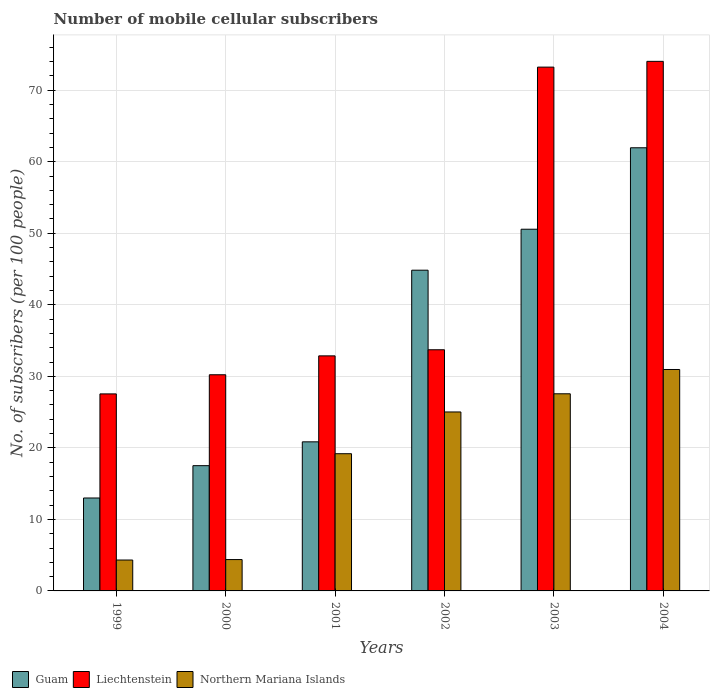How many groups of bars are there?
Your answer should be very brief. 6. Are the number of bars per tick equal to the number of legend labels?
Your answer should be very brief. Yes. Are the number of bars on each tick of the X-axis equal?
Offer a terse response. Yes. How many bars are there on the 3rd tick from the left?
Ensure brevity in your answer.  3. What is the label of the 5th group of bars from the left?
Keep it short and to the point. 2003. What is the number of mobile cellular subscribers in Guam in 2003?
Give a very brief answer. 50.56. Across all years, what is the maximum number of mobile cellular subscribers in Guam?
Provide a succinct answer. 61.95. Across all years, what is the minimum number of mobile cellular subscribers in Northern Mariana Islands?
Your answer should be very brief. 4.32. In which year was the number of mobile cellular subscribers in Liechtenstein minimum?
Make the answer very short. 1999. What is the total number of mobile cellular subscribers in Guam in the graph?
Make the answer very short. 208.69. What is the difference between the number of mobile cellular subscribers in Liechtenstein in 2000 and that in 2002?
Your response must be concise. -3.49. What is the difference between the number of mobile cellular subscribers in Northern Mariana Islands in 2000 and the number of mobile cellular subscribers in Guam in 2001?
Offer a terse response. -16.46. What is the average number of mobile cellular subscribers in Guam per year?
Provide a short and direct response. 34.78. In the year 2001, what is the difference between the number of mobile cellular subscribers in Northern Mariana Islands and number of mobile cellular subscribers in Liechtenstein?
Give a very brief answer. -13.68. What is the ratio of the number of mobile cellular subscribers in Northern Mariana Islands in 2000 to that in 2003?
Your answer should be compact. 0.16. Is the number of mobile cellular subscribers in Liechtenstein in 2001 less than that in 2003?
Give a very brief answer. Yes. Is the difference between the number of mobile cellular subscribers in Northern Mariana Islands in 2000 and 2004 greater than the difference between the number of mobile cellular subscribers in Liechtenstein in 2000 and 2004?
Your answer should be very brief. Yes. What is the difference between the highest and the second highest number of mobile cellular subscribers in Northern Mariana Islands?
Your answer should be compact. 3.4. What is the difference between the highest and the lowest number of mobile cellular subscribers in Liechtenstein?
Provide a succinct answer. 46.49. In how many years, is the number of mobile cellular subscribers in Northern Mariana Islands greater than the average number of mobile cellular subscribers in Northern Mariana Islands taken over all years?
Ensure brevity in your answer.  4. What does the 1st bar from the left in 1999 represents?
Keep it short and to the point. Guam. What does the 3rd bar from the right in 1999 represents?
Your answer should be very brief. Guam. How many years are there in the graph?
Keep it short and to the point. 6. Does the graph contain any zero values?
Offer a very short reply. No. How are the legend labels stacked?
Ensure brevity in your answer.  Horizontal. What is the title of the graph?
Your response must be concise. Number of mobile cellular subscribers. What is the label or title of the Y-axis?
Make the answer very short. No. of subscribers (per 100 people). What is the No. of subscribers (per 100 people) of Guam in 1999?
Ensure brevity in your answer.  12.99. What is the No. of subscribers (per 100 people) of Liechtenstein in 1999?
Provide a succinct answer. 27.54. What is the No. of subscribers (per 100 people) in Northern Mariana Islands in 1999?
Provide a short and direct response. 4.32. What is the No. of subscribers (per 100 people) of Guam in 2000?
Give a very brief answer. 17.51. What is the No. of subscribers (per 100 people) in Liechtenstein in 2000?
Make the answer very short. 30.22. What is the No. of subscribers (per 100 people) of Northern Mariana Islands in 2000?
Keep it short and to the point. 4.38. What is the No. of subscribers (per 100 people) of Guam in 2001?
Your answer should be very brief. 20.84. What is the No. of subscribers (per 100 people) of Liechtenstein in 2001?
Your response must be concise. 32.86. What is the No. of subscribers (per 100 people) of Northern Mariana Islands in 2001?
Keep it short and to the point. 19.18. What is the No. of subscribers (per 100 people) in Guam in 2002?
Offer a very short reply. 44.84. What is the No. of subscribers (per 100 people) of Liechtenstein in 2002?
Give a very brief answer. 33.71. What is the No. of subscribers (per 100 people) of Northern Mariana Islands in 2002?
Keep it short and to the point. 25.02. What is the No. of subscribers (per 100 people) in Guam in 2003?
Your response must be concise. 50.56. What is the No. of subscribers (per 100 people) in Liechtenstein in 2003?
Offer a terse response. 73.23. What is the No. of subscribers (per 100 people) in Northern Mariana Islands in 2003?
Make the answer very short. 27.56. What is the No. of subscribers (per 100 people) of Guam in 2004?
Provide a short and direct response. 61.95. What is the No. of subscribers (per 100 people) in Liechtenstein in 2004?
Offer a terse response. 74.03. What is the No. of subscribers (per 100 people) in Northern Mariana Islands in 2004?
Offer a terse response. 30.95. Across all years, what is the maximum No. of subscribers (per 100 people) of Guam?
Ensure brevity in your answer.  61.95. Across all years, what is the maximum No. of subscribers (per 100 people) in Liechtenstein?
Your answer should be compact. 74.03. Across all years, what is the maximum No. of subscribers (per 100 people) in Northern Mariana Islands?
Offer a terse response. 30.95. Across all years, what is the minimum No. of subscribers (per 100 people) in Guam?
Make the answer very short. 12.99. Across all years, what is the minimum No. of subscribers (per 100 people) of Liechtenstein?
Your answer should be very brief. 27.54. Across all years, what is the minimum No. of subscribers (per 100 people) in Northern Mariana Islands?
Your answer should be compact. 4.32. What is the total No. of subscribers (per 100 people) of Guam in the graph?
Offer a terse response. 208.69. What is the total No. of subscribers (per 100 people) in Liechtenstein in the graph?
Provide a succinct answer. 271.59. What is the total No. of subscribers (per 100 people) of Northern Mariana Islands in the graph?
Your answer should be very brief. 111.41. What is the difference between the No. of subscribers (per 100 people) of Guam in 1999 and that in 2000?
Keep it short and to the point. -4.52. What is the difference between the No. of subscribers (per 100 people) in Liechtenstein in 1999 and that in 2000?
Make the answer very short. -2.67. What is the difference between the No. of subscribers (per 100 people) of Northern Mariana Islands in 1999 and that in 2000?
Ensure brevity in your answer.  -0.07. What is the difference between the No. of subscribers (per 100 people) in Guam in 1999 and that in 2001?
Offer a very short reply. -7.85. What is the difference between the No. of subscribers (per 100 people) in Liechtenstein in 1999 and that in 2001?
Ensure brevity in your answer.  -5.32. What is the difference between the No. of subscribers (per 100 people) in Northern Mariana Islands in 1999 and that in 2001?
Ensure brevity in your answer.  -14.86. What is the difference between the No. of subscribers (per 100 people) in Guam in 1999 and that in 2002?
Provide a short and direct response. -31.84. What is the difference between the No. of subscribers (per 100 people) in Liechtenstein in 1999 and that in 2002?
Your answer should be very brief. -6.17. What is the difference between the No. of subscribers (per 100 people) of Northern Mariana Islands in 1999 and that in 2002?
Your answer should be compact. -20.7. What is the difference between the No. of subscribers (per 100 people) of Guam in 1999 and that in 2003?
Give a very brief answer. -37.57. What is the difference between the No. of subscribers (per 100 people) in Liechtenstein in 1999 and that in 2003?
Provide a short and direct response. -45.68. What is the difference between the No. of subscribers (per 100 people) in Northern Mariana Islands in 1999 and that in 2003?
Your response must be concise. -23.24. What is the difference between the No. of subscribers (per 100 people) of Guam in 1999 and that in 2004?
Provide a succinct answer. -48.96. What is the difference between the No. of subscribers (per 100 people) in Liechtenstein in 1999 and that in 2004?
Provide a succinct answer. -46.49. What is the difference between the No. of subscribers (per 100 people) of Northern Mariana Islands in 1999 and that in 2004?
Your answer should be compact. -26.64. What is the difference between the No. of subscribers (per 100 people) of Guam in 2000 and that in 2001?
Your answer should be very brief. -3.33. What is the difference between the No. of subscribers (per 100 people) of Liechtenstein in 2000 and that in 2001?
Your answer should be very brief. -2.64. What is the difference between the No. of subscribers (per 100 people) of Northern Mariana Islands in 2000 and that in 2001?
Your answer should be very brief. -14.8. What is the difference between the No. of subscribers (per 100 people) of Guam in 2000 and that in 2002?
Your answer should be very brief. -27.32. What is the difference between the No. of subscribers (per 100 people) in Liechtenstein in 2000 and that in 2002?
Your answer should be compact. -3.49. What is the difference between the No. of subscribers (per 100 people) of Northern Mariana Islands in 2000 and that in 2002?
Give a very brief answer. -20.63. What is the difference between the No. of subscribers (per 100 people) in Guam in 2000 and that in 2003?
Offer a terse response. -33.05. What is the difference between the No. of subscribers (per 100 people) in Liechtenstein in 2000 and that in 2003?
Ensure brevity in your answer.  -43.01. What is the difference between the No. of subscribers (per 100 people) of Northern Mariana Islands in 2000 and that in 2003?
Provide a succinct answer. -23.17. What is the difference between the No. of subscribers (per 100 people) of Guam in 2000 and that in 2004?
Give a very brief answer. -44.44. What is the difference between the No. of subscribers (per 100 people) of Liechtenstein in 2000 and that in 2004?
Keep it short and to the point. -43.81. What is the difference between the No. of subscribers (per 100 people) of Northern Mariana Islands in 2000 and that in 2004?
Offer a very short reply. -26.57. What is the difference between the No. of subscribers (per 100 people) in Guam in 2001 and that in 2002?
Give a very brief answer. -23.99. What is the difference between the No. of subscribers (per 100 people) in Liechtenstein in 2001 and that in 2002?
Ensure brevity in your answer.  -0.85. What is the difference between the No. of subscribers (per 100 people) of Northern Mariana Islands in 2001 and that in 2002?
Offer a terse response. -5.84. What is the difference between the No. of subscribers (per 100 people) in Guam in 2001 and that in 2003?
Offer a terse response. -29.72. What is the difference between the No. of subscribers (per 100 people) of Liechtenstein in 2001 and that in 2003?
Your answer should be very brief. -40.37. What is the difference between the No. of subscribers (per 100 people) in Northern Mariana Islands in 2001 and that in 2003?
Ensure brevity in your answer.  -8.38. What is the difference between the No. of subscribers (per 100 people) in Guam in 2001 and that in 2004?
Offer a terse response. -41.11. What is the difference between the No. of subscribers (per 100 people) in Liechtenstein in 2001 and that in 2004?
Your answer should be compact. -41.17. What is the difference between the No. of subscribers (per 100 people) of Northern Mariana Islands in 2001 and that in 2004?
Give a very brief answer. -11.77. What is the difference between the No. of subscribers (per 100 people) in Guam in 2002 and that in 2003?
Your answer should be very brief. -5.73. What is the difference between the No. of subscribers (per 100 people) of Liechtenstein in 2002 and that in 2003?
Your answer should be compact. -39.51. What is the difference between the No. of subscribers (per 100 people) of Northern Mariana Islands in 2002 and that in 2003?
Provide a succinct answer. -2.54. What is the difference between the No. of subscribers (per 100 people) in Guam in 2002 and that in 2004?
Ensure brevity in your answer.  -17.11. What is the difference between the No. of subscribers (per 100 people) of Liechtenstein in 2002 and that in 2004?
Your answer should be very brief. -40.32. What is the difference between the No. of subscribers (per 100 people) of Northern Mariana Islands in 2002 and that in 2004?
Provide a short and direct response. -5.94. What is the difference between the No. of subscribers (per 100 people) in Guam in 2003 and that in 2004?
Offer a very short reply. -11.39. What is the difference between the No. of subscribers (per 100 people) of Liechtenstein in 2003 and that in 2004?
Your answer should be very brief. -0.81. What is the difference between the No. of subscribers (per 100 people) in Northern Mariana Islands in 2003 and that in 2004?
Keep it short and to the point. -3.4. What is the difference between the No. of subscribers (per 100 people) of Guam in 1999 and the No. of subscribers (per 100 people) of Liechtenstein in 2000?
Offer a very short reply. -17.23. What is the difference between the No. of subscribers (per 100 people) in Guam in 1999 and the No. of subscribers (per 100 people) in Northern Mariana Islands in 2000?
Offer a very short reply. 8.61. What is the difference between the No. of subscribers (per 100 people) of Liechtenstein in 1999 and the No. of subscribers (per 100 people) of Northern Mariana Islands in 2000?
Offer a very short reply. 23.16. What is the difference between the No. of subscribers (per 100 people) in Guam in 1999 and the No. of subscribers (per 100 people) in Liechtenstein in 2001?
Ensure brevity in your answer.  -19.87. What is the difference between the No. of subscribers (per 100 people) in Guam in 1999 and the No. of subscribers (per 100 people) in Northern Mariana Islands in 2001?
Keep it short and to the point. -6.19. What is the difference between the No. of subscribers (per 100 people) in Liechtenstein in 1999 and the No. of subscribers (per 100 people) in Northern Mariana Islands in 2001?
Your response must be concise. 8.36. What is the difference between the No. of subscribers (per 100 people) of Guam in 1999 and the No. of subscribers (per 100 people) of Liechtenstein in 2002?
Make the answer very short. -20.72. What is the difference between the No. of subscribers (per 100 people) in Guam in 1999 and the No. of subscribers (per 100 people) in Northern Mariana Islands in 2002?
Offer a terse response. -12.03. What is the difference between the No. of subscribers (per 100 people) of Liechtenstein in 1999 and the No. of subscribers (per 100 people) of Northern Mariana Islands in 2002?
Provide a short and direct response. 2.53. What is the difference between the No. of subscribers (per 100 people) in Guam in 1999 and the No. of subscribers (per 100 people) in Liechtenstein in 2003?
Keep it short and to the point. -60.23. What is the difference between the No. of subscribers (per 100 people) of Guam in 1999 and the No. of subscribers (per 100 people) of Northern Mariana Islands in 2003?
Your answer should be very brief. -14.57. What is the difference between the No. of subscribers (per 100 people) in Liechtenstein in 1999 and the No. of subscribers (per 100 people) in Northern Mariana Islands in 2003?
Ensure brevity in your answer.  -0.02. What is the difference between the No. of subscribers (per 100 people) in Guam in 1999 and the No. of subscribers (per 100 people) in Liechtenstein in 2004?
Give a very brief answer. -61.04. What is the difference between the No. of subscribers (per 100 people) in Guam in 1999 and the No. of subscribers (per 100 people) in Northern Mariana Islands in 2004?
Keep it short and to the point. -17.96. What is the difference between the No. of subscribers (per 100 people) of Liechtenstein in 1999 and the No. of subscribers (per 100 people) of Northern Mariana Islands in 2004?
Ensure brevity in your answer.  -3.41. What is the difference between the No. of subscribers (per 100 people) of Guam in 2000 and the No. of subscribers (per 100 people) of Liechtenstein in 2001?
Offer a very short reply. -15.35. What is the difference between the No. of subscribers (per 100 people) in Guam in 2000 and the No. of subscribers (per 100 people) in Northern Mariana Islands in 2001?
Keep it short and to the point. -1.67. What is the difference between the No. of subscribers (per 100 people) of Liechtenstein in 2000 and the No. of subscribers (per 100 people) of Northern Mariana Islands in 2001?
Your answer should be very brief. 11.04. What is the difference between the No. of subscribers (per 100 people) of Guam in 2000 and the No. of subscribers (per 100 people) of Liechtenstein in 2002?
Provide a succinct answer. -16.2. What is the difference between the No. of subscribers (per 100 people) in Guam in 2000 and the No. of subscribers (per 100 people) in Northern Mariana Islands in 2002?
Your response must be concise. -7.51. What is the difference between the No. of subscribers (per 100 people) in Guam in 2000 and the No. of subscribers (per 100 people) in Liechtenstein in 2003?
Offer a terse response. -55.71. What is the difference between the No. of subscribers (per 100 people) in Guam in 2000 and the No. of subscribers (per 100 people) in Northern Mariana Islands in 2003?
Offer a very short reply. -10.05. What is the difference between the No. of subscribers (per 100 people) in Liechtenstein in 2000 and the No. of subscribers (per 100 people) in Northern Mariana Islands in 2003?
Offer a very short reply. 2.66. What is the difference between the No. of subscribers (per 100 people) of Guam in 2000 and the No. of subscribers (per 100 people) of Liechtenstein in 2004?
Keep it short and to the point. -56.52. What is the difference between the No. of subscribers (per 100 people) of Guam in 2000 and the No. of subscribers (per 100 people) of Northern Mariana Islands in 2004?
Ensure brevity in your answer.  -13.44. What is the difference between the No. of subscribers (per 100 people) of Liechtenstein in 2000 and the No. of subscribers (per 100 people) of Northern Mariana Islands in 2004?
Provide a short and direct response. -0.74. What is the difference between the No. of subscribers (per 100 people) in Guam in 2001 and the No. of subscribers (per 100 people) in Liechtenstein in 2002?
Ensure brevity in your answer.  -12.87. What is the difference between the No. of subscribers (per 100 people) of Guam in 2001 and the No. of subscribers (per 100 people) of Northern Mariana Islands in 2002?
Offer a terse response. -4.18. What is the difference between the No. of subscribers (per 100 people) of Liechtenstein in 2001 and the No. of subscribers (per 100 people) of Northern Mariana Islands in 2002?
Provide a succinct answer. 7.84. What is the difference between the No. of subscribers (per 100 people) in Guam in 2001 and the No. of subscribers (per 100 people) in Liechtenstein in 2003?
Offer a very short reply. -52.38. What is the difference between the No. of subscribers (per 100 people) of Guam in 2001 and the No. of subscribers (per 100 people) of Northern Mariana Islands in 2003?
Your answer should be compact. -6.72. What is the difference between the No. of subscribers (per 100 people) in Liechtenstein in 2001 and the No. of subscribers (per 100 people) in Northern Mariana Islands in 2003?
Your answer should be very brief. 5.3. What is the difference between the No. of subscribers (per 100 people) in Guam in 2001 and the No. of subscribers (per 100 people) in Liechtenstein in 2004?
Your answer should be compact. -53.19. What is the difference between the No. of subscribers (per 100 people) of Guam in 2001 and the No. of subscribers (per 100 people) of Northern Mariana Islands in 2004?
Keep it short and to the point. -10.11. What is the difference between the No. of subscribers (per 100 people) of Liechtenstein in 2001 and the No. of subscribers (per 100 people) of Northern Mariana Islands in 2004?
Make the answer very short. 1.91. What is the difference between the No. of subscribers (per 100 people) of Guam in 2002 and the No. of subscribers (per 100 people) of Liechtenstein in 2003?
Offer a terse response. -28.39. What is the difference between the No. of subscribers (per 100 people) in Guam in 2002 and the No. of subscribers (per 100 people) in Northern Mariana Islands in 2003?
Keep it short and to the point. 17.28. What is the difference between the No. of subscribers (per 100 people) in Liechtenstein in 2002 and the No. of subscribers (per 100 people) in Northern Mariana Islands in 2003?
Give a very brief answer. 6.15. What is the difference between the No. of subscribers (per 100 people) in Guam in 2002 and the No. of subscribers (per 100 people) in Liechtenstein in 2004?
Offer a very short reply. -29.2. What is the difference between the No. of subscribers (per 100 people) of Guam in 2002 and the No. of subscribers (per 100 people) of Northern Mariana Islands in 2004?
Your answer should be very brief. 13.88. What is the difference between the No. of subscribers (per 100 people) in Liechtenstein in 2002 and the No. of subscribers (per 100 people) in Northern Mariana Islands in 2004?
Your answer should be very brief. 2.76. What is the difference between the No. of subscribers (per 100 people) of Guam in 2003 and the No. of subscribers (per 100 people) of Liechtenstein in 2004?
Offer a very short reply. -23.47. What is the difference between the No. of subscribers (per 100 people) of Guam in 2003 and the No. of subscribers (per 100 people) of Northern Mariana Islands in 2004?
Offer a terse response. 19.61. What is the difference between the No. of subscribers (per 100 people) in Liechtenstein in 2003 and the No. of subscribers (per 100 people) in Northern Mariana Islands in 2004?
Your answer should be very brief. 42.27. What is the average No. of subscribers (per 100 people) of Guam per year?
Ensure brevity in your answer.  34.78. What is the average No. of subscribers (per 100 people) in Liechtenstein per year?
Provide a succinct answer. 45.27. What is the average No. of subscribers (per 100 people) in Northern Mariana Islands per year?
Provide a short and direct response. 18.57. In the year 1999, what is the difference between the No. of subscribers (per 100 people) in Guam and No. of subscribers (per 100 people) in Liechtenstein?
Offer a terse response. -14.55. In the year 1999, what is the difference between the No. of subscribers (per 100 people) in Guam and No. of subscribers (per 100 people) in Northern Mariana Islands?
Your answer should be very brief. 8.67. In the year 1999, what is the difference between the No. of subscribers (per 100 people) in Liechtenstein and No. of subscribers (per 100 people) in Northern Mariana Islands?
Keep it short and to the point. 23.22. In the year 2000, what is the difference between the No. of subscribers (per 100 people) of Guam and No. of subscribers (per 100 people) of Liechtenstein?
Your answer should be compact. -12.71. In the year 2000, what is the difference between the No. of subscribers (per 100 people) of Guam and No. of subscribers (per 100 people) of Northern Mariana Islands?
Make the answer very short. 13.13. In the year 2000, what is the difference between the No. of subscribers (per 100 people) in Liechtenstein and No. of subscribers (per 100 people) in Northern Mariana Islands?
Your answer should be compact. 25.83. In the year 2001, what is the difference between the No. of subscribers (per 100 people) of Guam and No. of subscribers (per 100 people) of Liechtenstein?
Offer a terse response. -12.02. In the year 2001, what is the difference between the No. of subscribers (per 100 people) of Guam and No. of subscribers (per 100 people) of Northern Mariana Islands?
Provide a short and direct response. 1.66. In the year 2001, what is the difference between the No. of subscribers (per 100 people) in Liechtenstein and No. of subscribers (per 100 people) in Northern Mariana Islands?
Your answer should be very brief. 13.68. In the year 2002, what is the difference between the No. of subscribers (per 100 people) in Guam and No. of subscribers (per 100 people) in Liechtenstein?
Offer a very short reply. 11.12. In the year 2002, what is the difference between the No. of subscribers (per 100 people) in Guam and No. of subscribers (per 100 people) in Northern Mariana Islands?
Ensure brevity in your answer.  19.82. In the year 2002, what is the difference between the No. of subscribers (per 100 people) in Liechtenstein and No. of subscribers (per 100 people) in Northern Mariana Islands?
Your response must be concise. 8.69. In the year 2003, what is the difference between the No. of subscribers (per 100 people) in Guam and No. of subscribers (per 100 people) in Liechtenstein?
Your response must be concise. -22.66. In the year 2003, what is the difference between the No. of subscribers (per 100 people) of Guam and No. of subscribers (per 100 people) of Northern Mariana Islands?
Your answer should be very brief. 23. In the year 2003, what is the difference between the No. of subscribers (per 100 people) of Liechtenstein and No. of subscribers (per 100 people) of Northern Mariana Islands?
Your response must be concise. 45.67. In the year 2004, what is the difference between the No. of subscribers (per 100 people) of Guam and No. of subscribers (per 100 people) of Liechtenstein?
Give a very brief answer. -12.08. In the year 2004, what is the difference between the No. of subscribers (per 100 people) in Guam and No. of subscribers (per 100 people) in Northern Mariana Islands?
Make the answer very short. 31. In the year 2004, what is the difference between the No. of subscribers (per 100 people) of Liechtenstein and No. of subscribers (per 100 people) of Northern Mariana Islands?
Your answer should be very brief. 43.08. What is the ratio of the No. of subscribers (per 100 people) of Guam in 1999 to that in 2000?
Your answer should be compact. 0.74. What is the ratio of the No. of subscribers (per 100 people) in Liechtenstein in 1999 to that in 2000?
Ensure brevity in your answer.  0.91. What is the ratio of the No. of subscribers (per 100 people) of Northern Mariana Islands in 1999 to that in 2000?
Your answer should be compact. 0.99. What is the ratio of the No. of subscribers (per 100 people) in Guam in 1999 to that in 2001?
Your response must be concise. 0.62. What is the ratio of the No. of subscribers (per 100 people) of Liechtenstein in 1999 to that in 2001?
Offer a very short reply. 0.84. What is the ratio of the No. of subscribers (per 100 people) of Northern Mariana Islands in 1999 to that in 2001?
Your response must be concise. 0.23. What is the ratio of the No. of subscribers (per 100 people) in Guam in 1999 to that in 2002?
Keep it short and to the point. 0.29. What is the ratio of the No. of subscribers (per 100 people) of Liechtenstein in 1999 to that in 2002?
Make the answer very short. 0.82. What is the ratio of the No. of subscribers (per 100 people) of Northern Mariana Islands in 1999 to that in 2002?
Ensure brevity in your answer.  0.17. What is the ratio of the No. of subscribers (per 100 people) in Guam in 1999 to that in 2003?
Provide a short and direct response. 0.26. What is the ratio of the No. of subscribers (per 100 people) in Liechtenstein in 1999 to that in 2003?
Make the answer very short. 0.38. What is the ratio of the No. of subscribers (per 100 people) of Northern Mariana Islands in 1999 to that in 2003?
Keep it short and to the point. 0.16. What is the ratio of the No. of subscribers (per 100 people) of Guam in 1999 to that in 2004?
Offer a terse response. 0.21. What is the ratio of the No. of subscribers (per 100 people) of Liechtenstein in 1999 to that in 2004?
Provide a short and direct response. 0.37. What is the ratio of the No. of subscribers (per 100 people) of Northern Mariana Islands in 1999 to that in 2004?
Your answer should be compact. 0.14. What is the ratio of the No. of subscribers (per 100 people) in Guam in 2000 to that in 2001?
Your answer should be compact. 0.84. What is the ratio of the No. of subscribers (per 100 people) of Liechtenstein in 2000 to that in 2001?
Your answer should be compact. 0.92. What is the ratio of the No. of subscribers (per 100 people) in Northern Mariana Islands in 2000 to that in 2001?
Keep it short and to the point. 0.23. What is the ratio of the No. of subscribers (per 100 people) of Guam in 2000 to that in 2002?
Provide a short and direct response. 0.39. What is the ratio of the No. of subscribers (per 100 people) in Liechtenstein in 2000 to that in 2002?
Offer a very short reply. 0.9. What is the ratio of the No. of subscribers (per 100 people) in Northern Mariana Islands in 2000 to that in 2002?
Offer a terse response. 0.18. What is the ratio of the No. of subscribers (per 100 people) in Guam in 2000 to that in 2003?
Provide a succinct answer. 0.35. What is the ratio of the No. of subscribers (per 100 people) in Liechtenstein in 2000 to that in 2003?
Provide a succinct answer. 0.41. What is the ratio of the No. of subscribers (per 100 people) of Northern Mariana Islands in 2000 to that in 2003?
Your response must be concise. 0.16. What is the ratio of the No. of subscribers (per 100 people) of Guam in 2000 to that in 2004?
Your answer should be compact. 0.28. What is the ratio of the No. of subscribers (per 100 people) of Liechtenstein in 2000 to that in 2004?
Your response must be concise. 0.41. What is the ratio of the No. of subscribers (per 100 people) of Northern Mariana Islands in 2000 to that in 2004?
Make the answer very short. 0.14. What is the ratio of the No. of subscribers (per 100 people) of Guam in 2001 to that in 2002?
Give a very brief answer. 0.46. What is the ratio of the No. of subscribers (per 100 people) in Liechtenstein in 2001 to that in 2002?
Give a very brief answer. 0.97. What is the ratio of the No. of subscribers (per 100 people) of Northern Mariana Islands in 2001 to that in 2002?
Provide a succinct answer. 0.77. What is the ratio of the No. of subscribers (per 100 people) of Guam in 2001 to that in 2003?
Offer a very short reply. 0.41. What is the ratio of the No. of subscribers (per 100 people) in Liechtenstein in 2001 to that in 2003?
Offer a very short reply. 0.45. What is the ratio of the No. of subscribers (per 100 people) of Northern Mariana Islands in 2001 to that in 2003?
Make the answer very short. 0.7. What is the ratio of the No. of subscribers (per 100 people) in Guam in 2001 to that in 2004?
Offer a terse response. 0.34. What is the ratio of the No. of subscribers (per 100 people) of Liechtenstein in 2001 to that in 2004?
Provide a short and direct response. 0.44. What is the ratio of the No. of subscribers (per 100 people) of Northern Mariana Islands in 2001 to that in 2004?
Give a very brief answer. 0.62. What is the ratio of the No. of subscribers (per 100 people) in Guam in 2002 to that in 2003?
Offer a very short reply. 0.89. What is the ratio of the No. of subscribers (per 100 people) in Liechtenstein in 2002 to that in 2003?
Offer a very short reply. 0.46. What is the ratio of the No. of subscribers (per 100 people) in Northern Mariana Islands in 2002 to that in 2003?
Provide a succinct answer. 0.91. What is the ratio of the No. of subscribers (per 100 people) of Guam in 2002 to that in 2004?
Provide a short and direct response. 0.72. What is the ratio of the No. of subscribers (per 100 people) in Liechtenstein in 2002 to that in 2004?
Offer a terse response. 0.46. What is the ratio of the No. of subscribers (per 100 people) of Northern Mariana Islands in 2002 to that in 2004?
Make the answer very short. 0.81. What is the ratio of the No. of subscribers (per 100 people) in Guam in 2003 to that in 2004?
Give a very brief answer. 0.82. What is the ratio of the No. of subscribers (per 100 people) in Liechtenstein in 2003 to that in 2004?
Ensure brevity in your answer.  0.99. What is the ratio of the No. of subscribers (per 100 people) in Northern Mariana Islands in 2003 to that in 2004?
Provide a succinct answer. 0.89. What is the difference between the highest and the second highest No. of subscribers (per 100 people) in Guam?
Offer a very short reply. 11.39. What is the difference between the highest and the second highest No. of subscribers (per 100 people) of Liechtenstein?
Make the answer very short. 0.81. What is the difference between the highest and the second highest No. of subscribers (per 100 people) in Northern Mariana Islands?
Your answer should be compact. 3.4. What is the difference between the highest and the lowest No. of subscribers (per 100 people) of Guam?
Make the answer very short. 48.96. What is the difference between the highest and the lowest No. of subscribers (per 100 people) in Liechtenstein?
Ensure brevity in your answer.  46.49. What is the difference between the highest and the lowest No. of subscribers (per 100 people) in Northern Mariana Islands?
Your response must be concise. 26.64. 